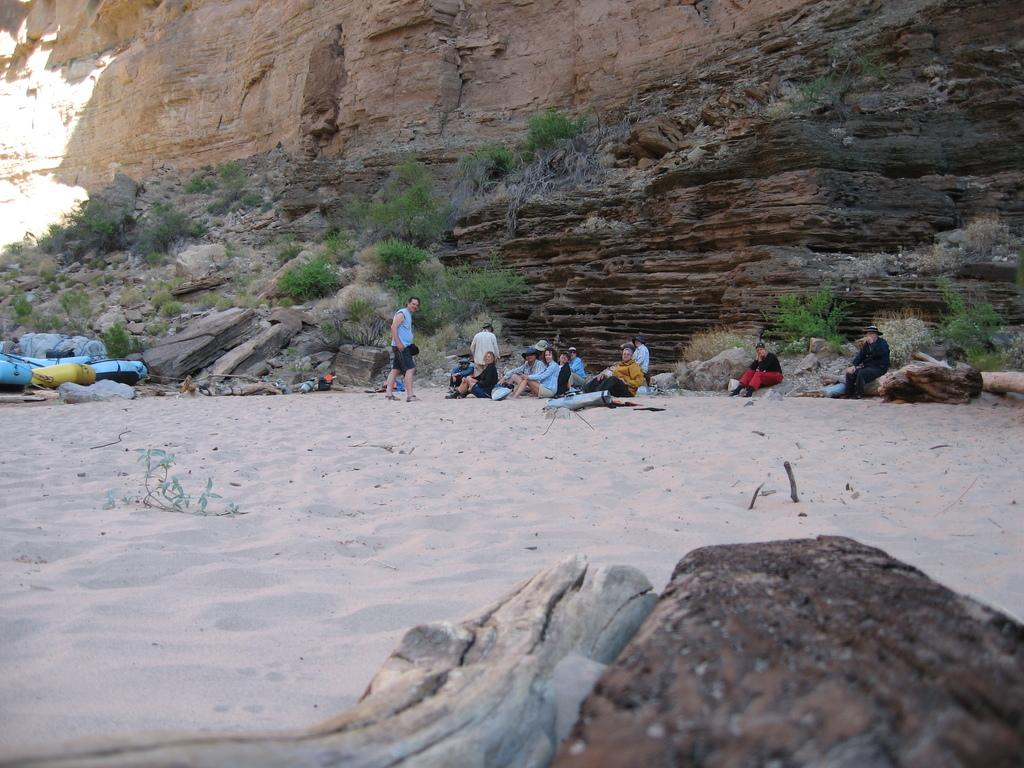What can be seen in the background of the image? There is a mountain in the background of the image. What are the people in the image doing? The people are sitting in the sand. Can you describe any other objects or features in the image? There is a rock at the bottom of the image. What type of button is being requested by the person in the image? There is no person in the image making a request for a button, nor is there any button present in the image. How many trees are visible in the image? There are no trees visible in the image; it features a mountain, people sitting in the sand, and a rock. 